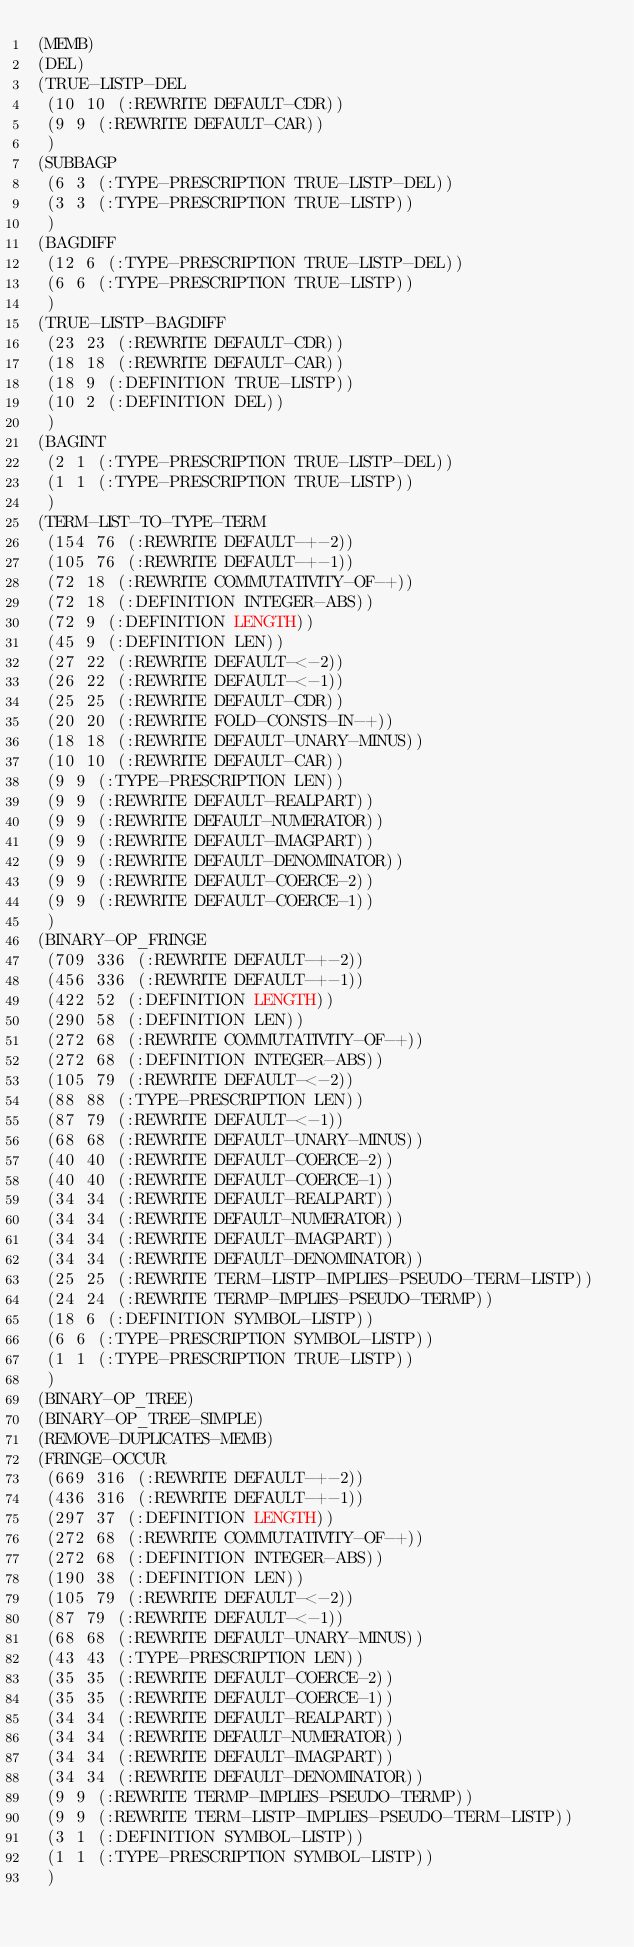<code> <loc_0><loc_0><loc_500><loc_500><_Lisp_>(MEMB)
(DEL)
(TRUE-LISTP-DEL
 (10 10 (:REWRITE DEFAULT-CDR))
 (9 9 (:REWRITE DEFAULT-CAR))
 )
(SUBBAGP
 (6 3 (:TYPE-PRESCRIPTION TRUE-LISTP-DEL))
 (3 3 (:TYPE-PRESCRIPTION TRUE-LISTP))
 )
(BAGDIFF
 (12 6 (:TYPE-PRESCRIPTION TRUE-LISTP-DEL))
 (6 6 (:TYPE-PRESCRIPTION TRUE-LISTP))
 )
(TRUE-LISTP-BAGDIFF
 (23 23 (:REWRITE DEFAULT-CDR))
 (18 18 (:REWRITE DEFAULT-CAR))
 (18 9 (:DEFINITION TRUE-LISTP))
 (10 2 (:DEFINITION DEL))
 )
(BAGINT
 (2 1 (:TYPE-PRESCRIPTION TRUE-LISTP-DEL))
 (1 1 (:TYPE-PRESCRIPTION TRUE-LISTP))
 )
(TERM-LIST-TO-TYPE-TERM
 (154 76 (:REWRITE DEFAULT-+-2))
 (105 76 (:REWRITE DEFAULT-+-1))
 (72 18 (:REWRITE COMMUTATIVITY-OF-+))
 (72 18 (:DEFINITION INTEGER-ABS))
 (72 9 (:DEFINITION LENGTH))
 (45 9 (:DEFINITION LEN))
 (27 22 (:REWRITE DEFAULT-<-2))
 (26 22 (:REWRITE DEFAULT-<-1))
 (25 25 (:REWRITE DEFAULT-CDR))
 (20 20 (:REWRITE FOLD-CONSTS-IN-+))
 (18 18 (:REWRITE DEFAULT-UNARY-MINUS))
 (10 10 (:REWRITE DEFAULT-CAR))
 (9 9 (:TYPE-PRESCRIPTION LEN))
 (9 9 (:REWRITE DEFAULT-REALPART))
 (9 9 (:REWRITE DEFAULT-NUMERATOR))
 (9 9 (:REWRITE DEFAULT-IMAGPART))
 (9 9 (:REWRITE DEFAULT-DENOMINATOR))
 (9 9 (:REWRITE DEFAULT-COERCE-2))
 (9 9 (:REWRITE DEFAULT-COERCE-1))
 )
(BINARY-OP_FRINGE
 (709 336 (:REWRITE DEFAULT-+-2))
 (456 336 (:REWRITE DEFAULT-+-1))
 (422 52 (:DEFINITION LENGTH))
 (290 58 (:DEFINITION LEN))
 (272 68 (:REWRITE COMMUTATIVITY-OF-+))
 (272 68 (:DEFINITION INTEGER-ABS))
 (105 79 (:REWRITE DEFAULT-<-2))
 (88 88 (:TYPE-PRESCRIPTION LEN))
 (87 79 (:REWRITE DEFAULT-<-1))
 (68 68 (:REWRITE DEFAULT-UNARY-MINUS))
 (40 40 (:REWRITE DEFAULT-COERCE-2))
 (40 40 (:REWRITE DEFAULT-COERCE-1))
 (34 34 (:REWRITE DEFAULT-REALPART))
 (34 34 (:REWRITE DEFAULT-NUMERATOR))
 (34 34 (:REWRITE DEFAULT-IMAGPART))
 (34 34 (:REWRITE DEFAULT-DENOMINATOR))
 (25 25 (:REWRITE TERM-LISTP-IMPLIES-PSEUDO-TERM-LISTP))
 (24 24 (:REWRITE TERMP-IMPLIES-PSEUDO-TERMP))
 (18 6 (:DEFINITION SYMBOL-LISTP))
 (6 6 (:TYPE-PRESCRIPTION SYMBOL-LISTP))
 (1 1 (:TYPE-PRESCRIPTION TRUE-LISTP))
 )
(BINARY-OP_TREE)
(BINARY-OP_TREE-SIMPLE)
(REMOVE-DUPLICATES-MEMB)
(FRINGE-OCCUR
 (669 316 (:REWRITE DEFAULT-+-2))
 (436 316 (:REWRITE DEFAULT-+-1))
 (297 37 (:DEFINITION LENGTH))
 (272 68 (:REWRITE COMMUTATIVITY-OF-+))
 (272 68 (:DEFINITION INTEGER-ABS))
 (190 38 (:DEFINITION LEN))
 (105 79 (:REWRITE DEFAULT-<-2))
 (87 79 (:REWRITE DEFAULT-<-1))
 (68 68 (:REWRITE DEFAULT-UNARY-MINUS))
 (43 43 (:TYPE-PRESCRIPTION LEN))
 (35 35 (:REWRITE DEFAULT-COERCE-2))
 (35 35 (:REWRITE DEFAULT-COERCE-1))
 (34 34 (:REWRITE DEFAULT-REALPART))
 (34 34 (:REWRITE DEFAULT-NUMERATOR))
 (34 34 (:REWRITE DEFAULT-IMAGPART))
 (34 34 (:REWRITE DEFAULT-DENOMINATOR))
 (9 9 (:REWRITE TERMP-IMPLIES-PSEUDO-TERMP))
 (9 9 (:REWRITE TERM-LISTP-IMPLIES-PSEUDO-TERM-LISTP))
 (3 1 (:DEFINITION SYMBOL-LISTP))
 (1 1 (:TYPE-PRESCRIPTION SYMBOL-LISTP))
 )
</code> 